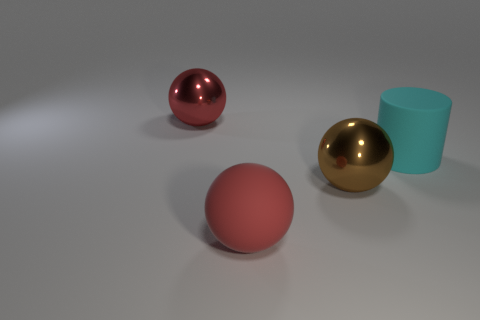Subtract all shiny spheres. How many spheres are left? 1 Subtract all green cubes. How many red spheres are left? 2 Add 2 red metal objects. How many objects exist? 6 Subtract all spheres. How many objects are left? 1 Add 2 red metal spheres. How many red metal spheres exist? 3 Subtract 0 blue blocks. How many objects are left? 4 Subtract all green spheres. Subtract all cyan cubes. How many spheres are left? 3 Subtract all big red rubber things. Subtract all red things. How many objects are left? 1 Add 3 red metal spheres. How many red metal spheres are left? 4 